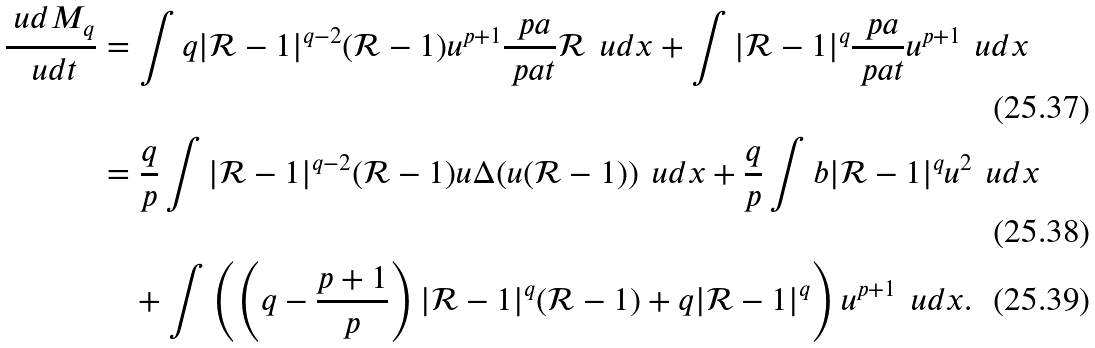Convert formula to latex. <formula><loc_0><loc_0><loc_500><loc_500>\frac { \ u d M _ { q } } { \ u d t } & = \int q | \mathcal { R } - 1 | ^ { q - 2 } ( \mathcal { R } - 1 ) u ^ { p + 1 } \frac { \ p a } { \ p a t } \mathcal { R } \, \ u d x + \int | \mathcal { R } - 1 | ^ { q } \frac { \ p a } { \ p a t } u ^ { p + 1 } \, \ u d x \\ & = \frac { q } { p } \int | \mathcal { R } - 1 | ^ { q - 2 } ( \mathcal { R } - 1 ) u \Delta ( u ( \mathcal { R } - 1 ) ) \, \ u d x + \frac { q } { p } \int b | \mathcal { R } - 1 | ^ { q } u ^ { 2 } \, \ u d x \\ & \quad + \int \left ( \left ( q - \frac { p + 1 } { p } \right ) | \mathcal { R } - 1 | ^ { q } ( \mathcal { R } - 1 ) + q | \mathcal { R } - 1 | ^ { q } \right ) u ^ { p + 1 } \, \ u d x .</formula> 